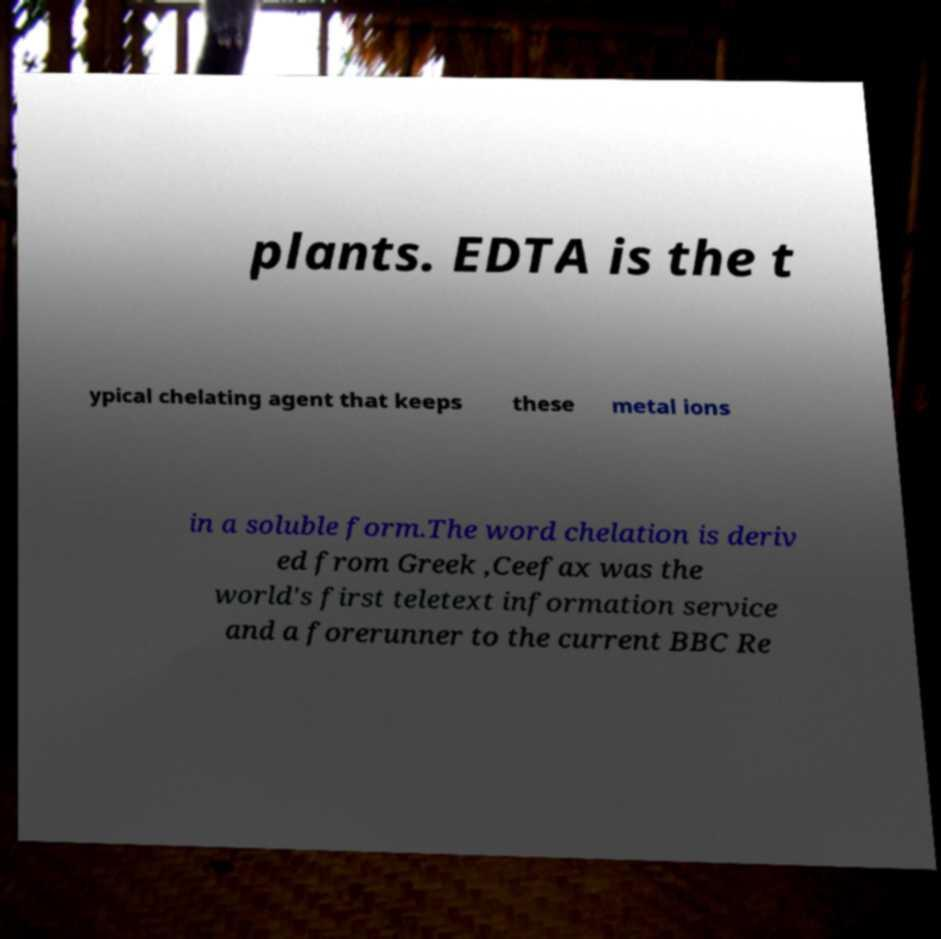Could you assist in decoding the text presented in this image and type it out clearly? plants. EDTA is the t ypical chelating agent that keeps these metal ions in a soluble form.The word chelation is deriv ed from Greek ,Ceefax was the world's first teletext information service and a forerunner to the current BBC Re 